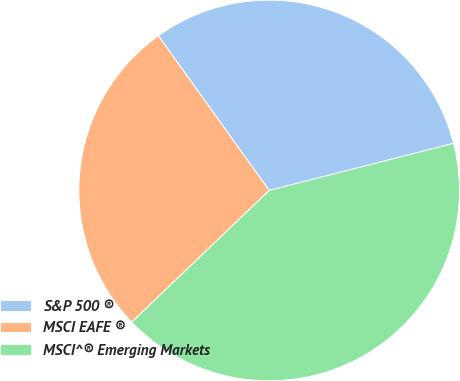Convert chart. <chart><loc_0><loc_0><loc_500><loc_500><pie_chart><fcel>S&P 500 ®<fcel>MSCI EAFE ®<fcel>MSCI^® Emerging Markets<nl><fcel>30.91%<fcel>27.27%<fcel>41.82%<nl></chart> 